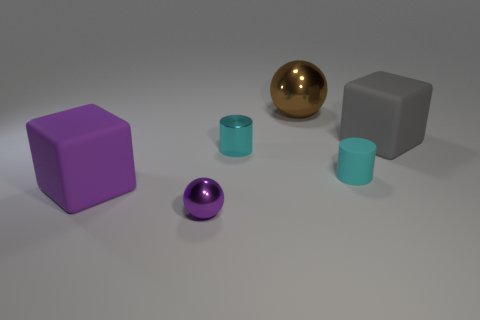How do the different shapes in the image relate to each other? The arrangement of shapes demonstrates a balance between right-angled geometry, as seen with the cubes, and the smooth, round forms of the spheres and cylinder. This contrast creates visual interest and can be reflective of how various shapes can coexist in a harmonically composed space. 